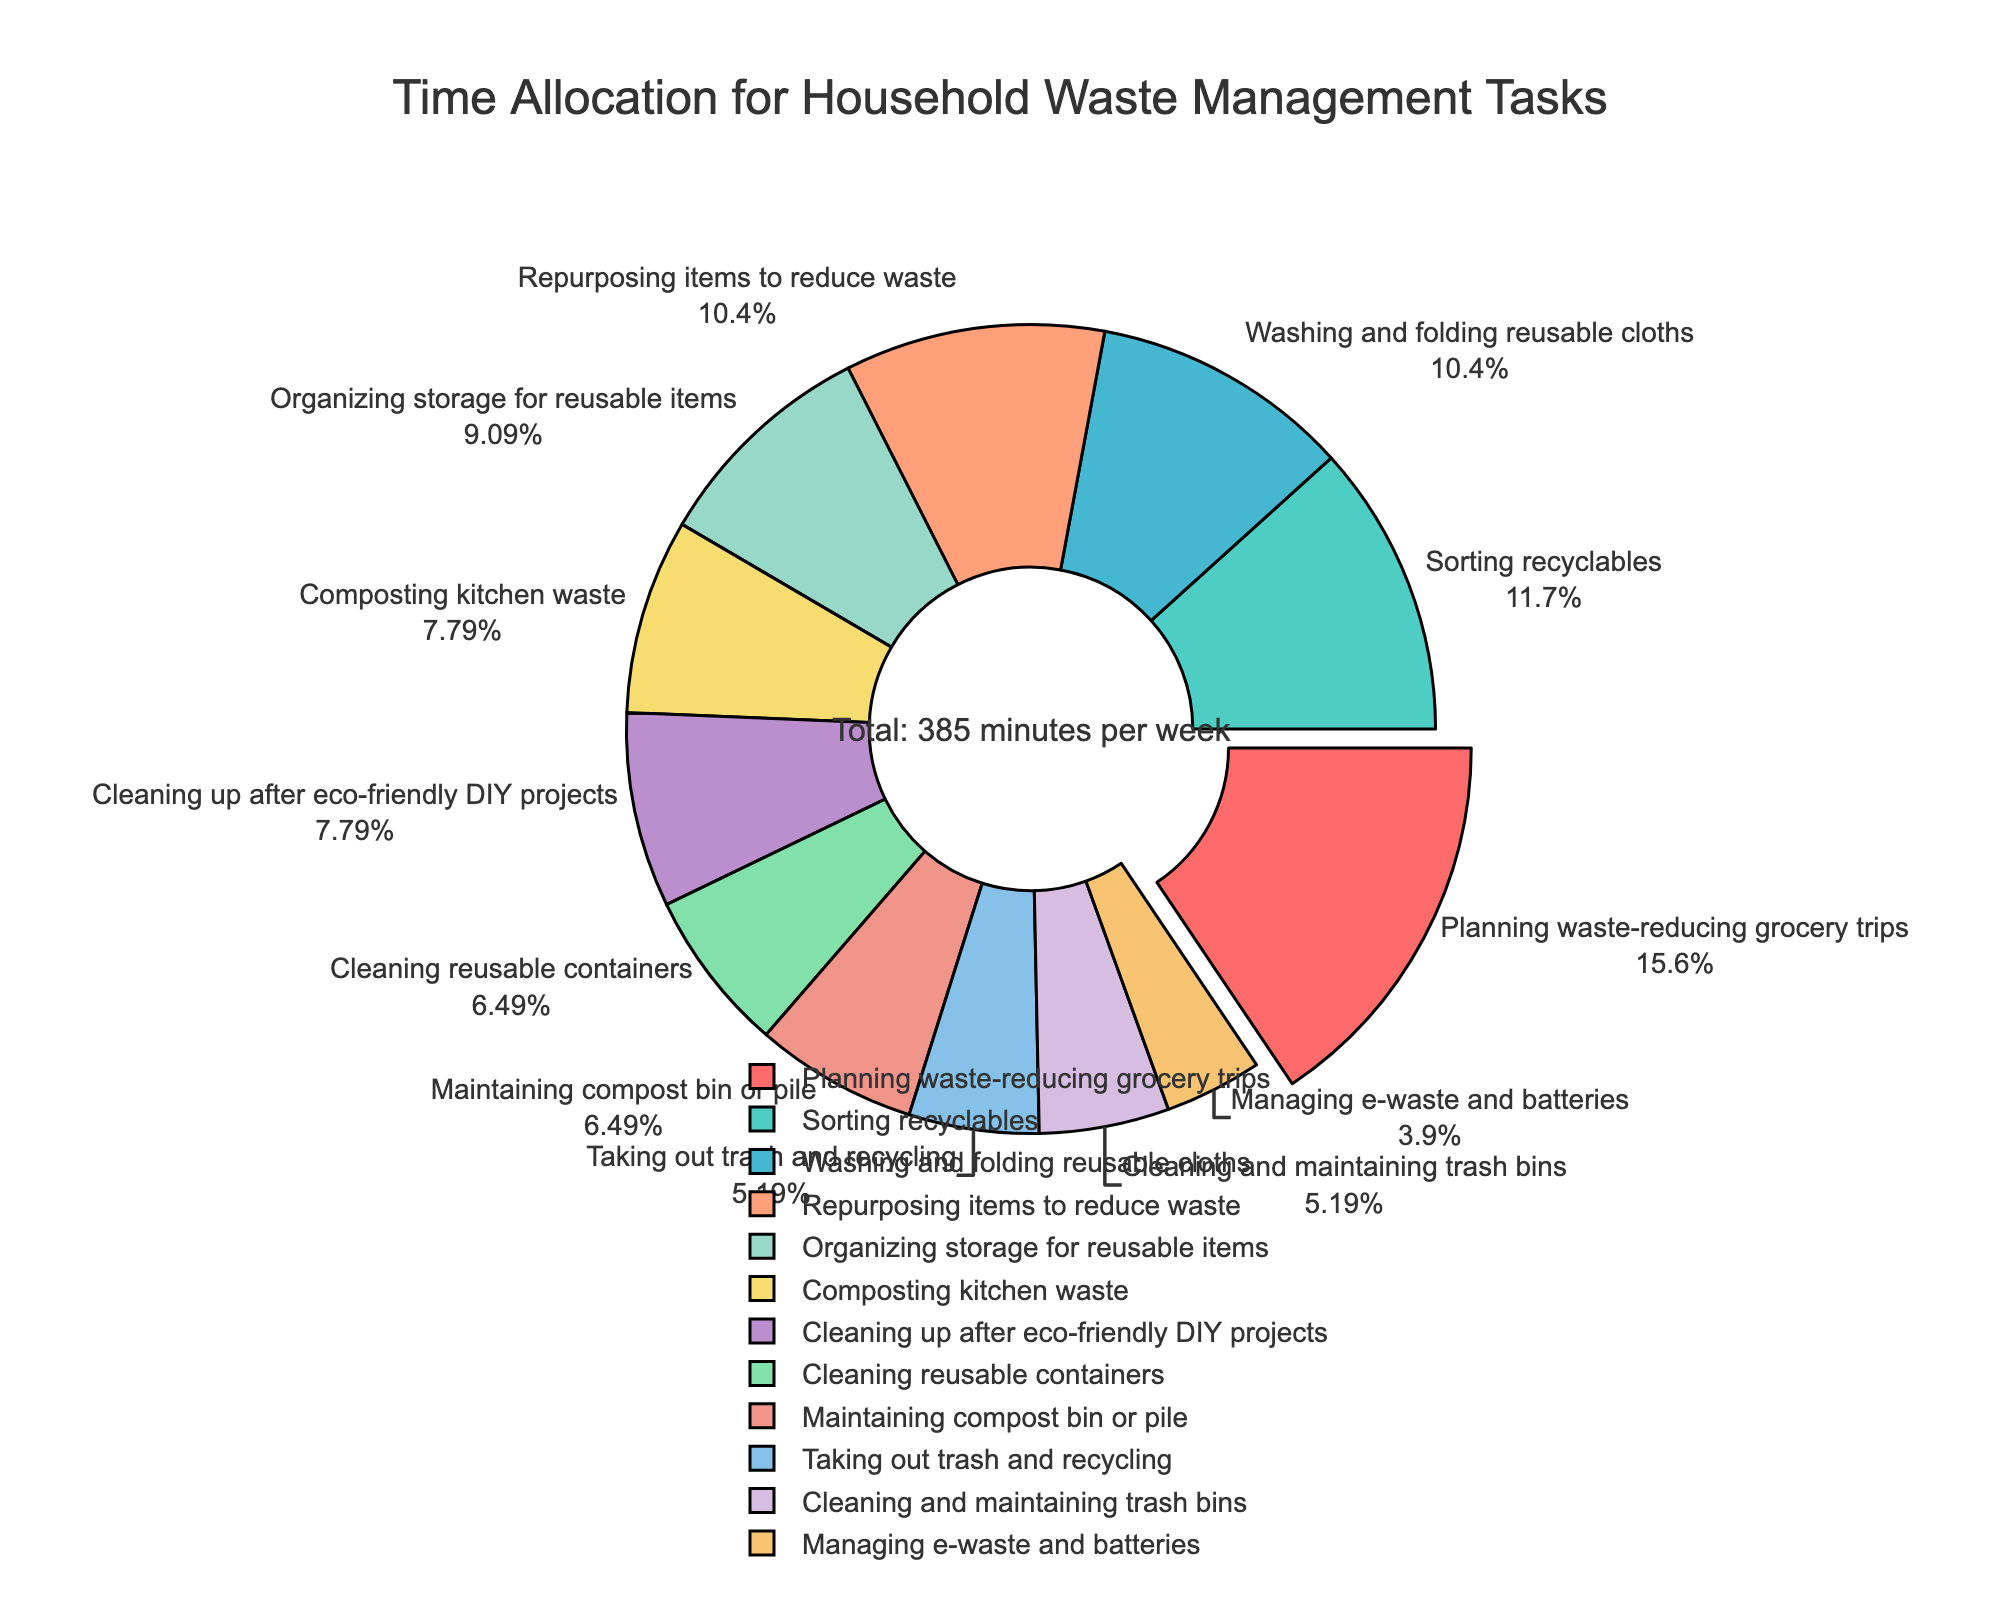Which task takes up the most time in a week? To find the task that takes up the most time, look for the largest segment in the pie chart. The task with the label showing 'Planning waste-reducing grocery trips' has the largest percentage, indicating it takes the most time.
Answer: Planning waste-reducing grocery trips Which task has a 10% pull-out from the pie? Look for the segment that is slightly pulled out from the rest of the pie chart. The one pulled out the most is 'Planning waste-reducing grocery trips,' which confirms a special 10% pull.
Answer: Planning waste-reducing grocery trips What percentage of the week is spent on composting kitchen waste? Locate the 'Composting kitchen waste' segment and its associated percentage value shown on the chart. It shows 'Composting kitchen waste' is 6% of the total time.
Answer: 6% How much total time is spent on managing e-waste and batteries and cleaning and maintaining trash bins? Add the percentages of 'Managing e-waste and batteries' and 'Cleaning and maintaining trash bins' from the chart. 'Managing e-waste and batteries' is 3% and 'Cleaning and maintaining trash bins' is 4%. So the total is 3% + 4% = 7%.
Answer: 7% Is sorting recyclables taking more time than washing and folding reusable cloths? Compare the percentages for 'Sorting recyclables' and 'Washing and folding reusable cloths.' 'Sorting recyclables' is 9% and 'Washing and folding reusable cloths' is 8%. Since 9% > 8%, sorting recyclables takes more time.
Answer: Yes Which color represents the time spent on organizing storage for reusable items? Identify the segment labeled 'Organizing storage for reusable items' and check its color. The chart uses green for this task.
Answer: Green What two tasks have the same amount of time allocated? Identify two segments with the same percentage. Both 'Cleaning and maintaining trash bins' and 'Taking out trash and recycling' have 4% each on the chart.
Answer: Cleaning and maintaining trash bins, Taking out trash and recycling How much time is spent on tasks related to composting? Add the percentages of 'Composting kitchen waste' and 'Maintaining compost bin or pile.' 'Composting kitchen waste' is 6% and 'Maintaining compost bin or pile' is 5%. 6% + 5% = 11% of the total time each week.
Answer: 11% Which is the smallest task portion-wise on the pie chart? Determine the segment with the smallest percentage. 'Managing e-waste and batteries,' with 3%, is the smallest segment on the chart.
Answer: Managing e-waste and batteries How does the time for planning waste-reducing grocery trips compare against cleaning up after eco-friendly DIY projects? Compare the percentages of 'Planning waste-reducing grocery trips' and 'Cleaning up after eco-friendly DIY projects.' 'Planning waste-reducing grocery trips' is 12% and 'Cleaning up after eco-friendly DIY projects' is 6%. Since 12% > 6%, 'Planning waste-reducing grocery trips' takes more time.
Answer: More 